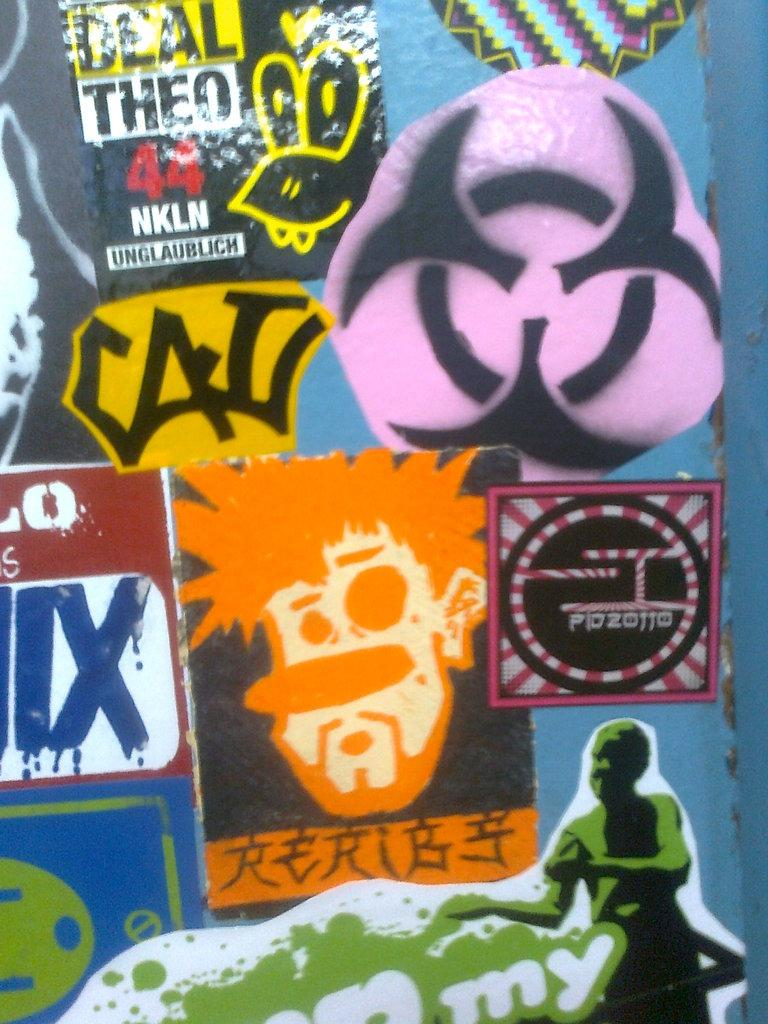Provide a one-sentence caption for the provided image. Closeup of various graffiti stickers including one reading CAL. 